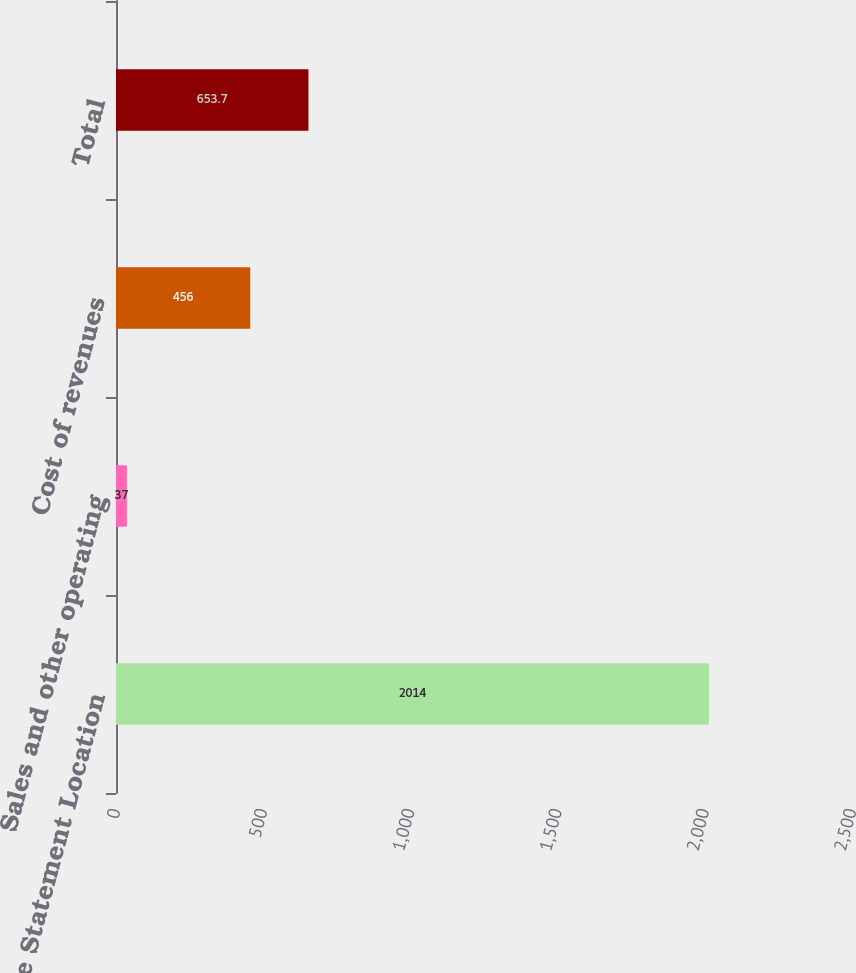Convert chart to OTSL. <chart><loc_0><loc_0><loc_500><loc_500><bar_chart><fcel>Income Statement Location<fcel>Sales and other operating<fcel>Cost of revenues<fcel>Total<nl><fcel>2014<fcel>37<fcel>456<fcel>653.7<nl></chart> 